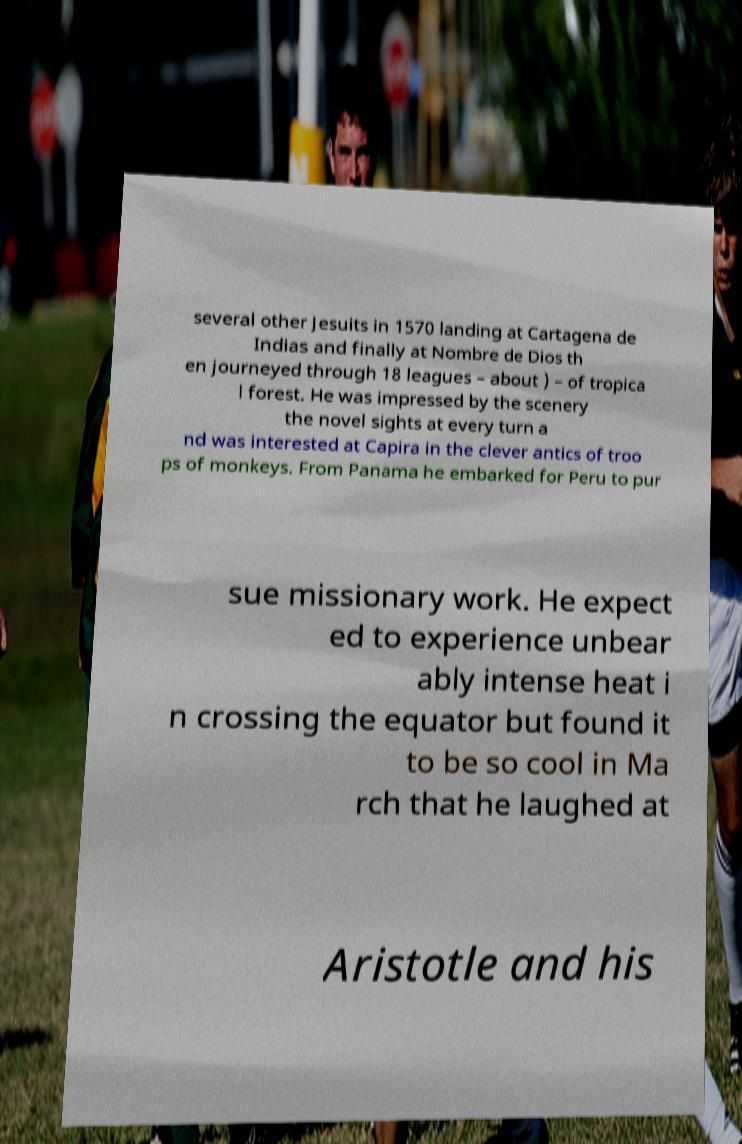Can you accurately transcribe the text from the provided image for me? several other Jesuits in 1570 landing at Cartagena de Indias and finally at Nombre de Dios th en journeyed through 18 leagues – about ) – of tropica l forest. He was impressed by the scenery the novel sights at every turn a nd was interested at Capira in the clever antics of troo ps of monkeys. From Panama he embarked for Peru to pur sue missionary work. He expect ed to experience unbear ably intense heat i n crossing the equator but found it to be so cool in Ma rch that he laughed at Aristotle and his 